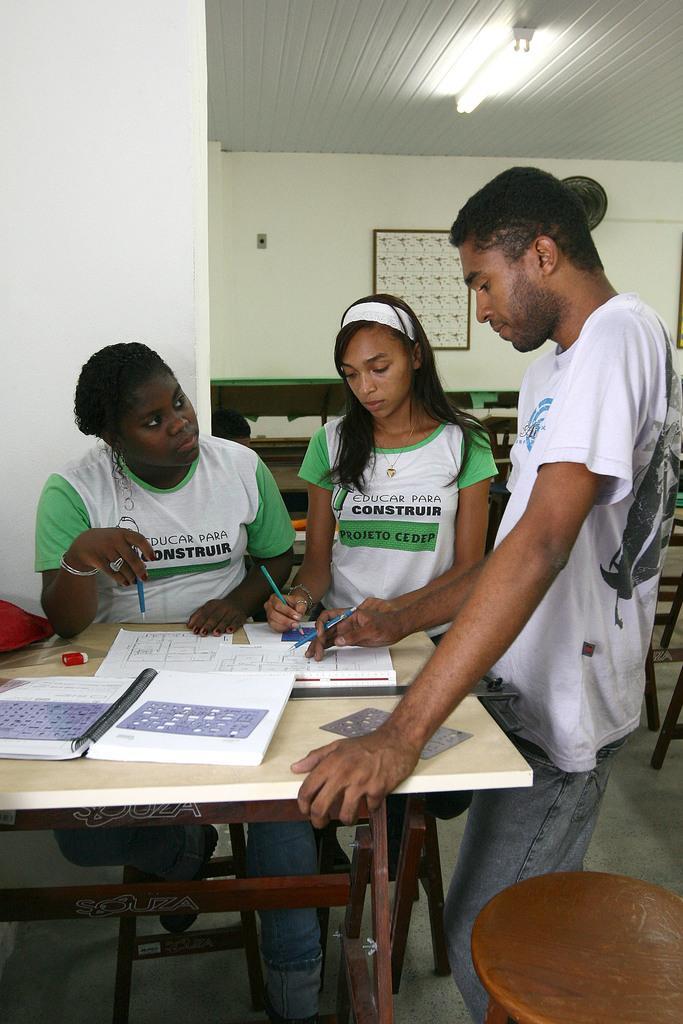Describe this image in one or two sentences. This picture is of inside. On the right there is a Man wearing white color t-shirt and standing and holding a pen and there is a stool placed on the ground. In the center there is a table on the top of which there is a book and some papers are placed. In the center there is a woman wearing white color t-shirt, holding pen and standing. On the left there is a person, holding pen and sitting on the chair. In the background there is a picture frame hanging on the wall. 